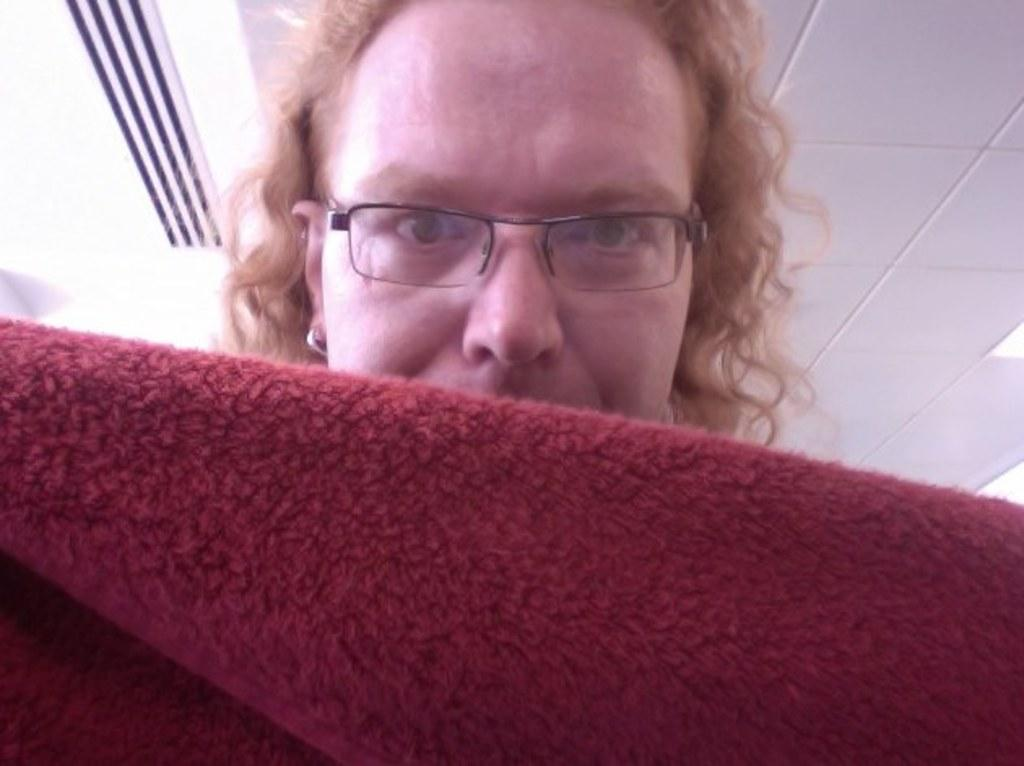What can be seen in the image? There is a person in the image. Can you describe the person's appearance? The person has long hair and is wearing spectacles. What is the person holding in the image? The person is holding a cloth. What can be seen in the background of the image? There are lights and an air conditioner vent in the background of the image. What type of creature is hiding behind the air conditioner vent in the image? There is no creature visible in the image, and no creature is hiding behind the air conditioner vent. 